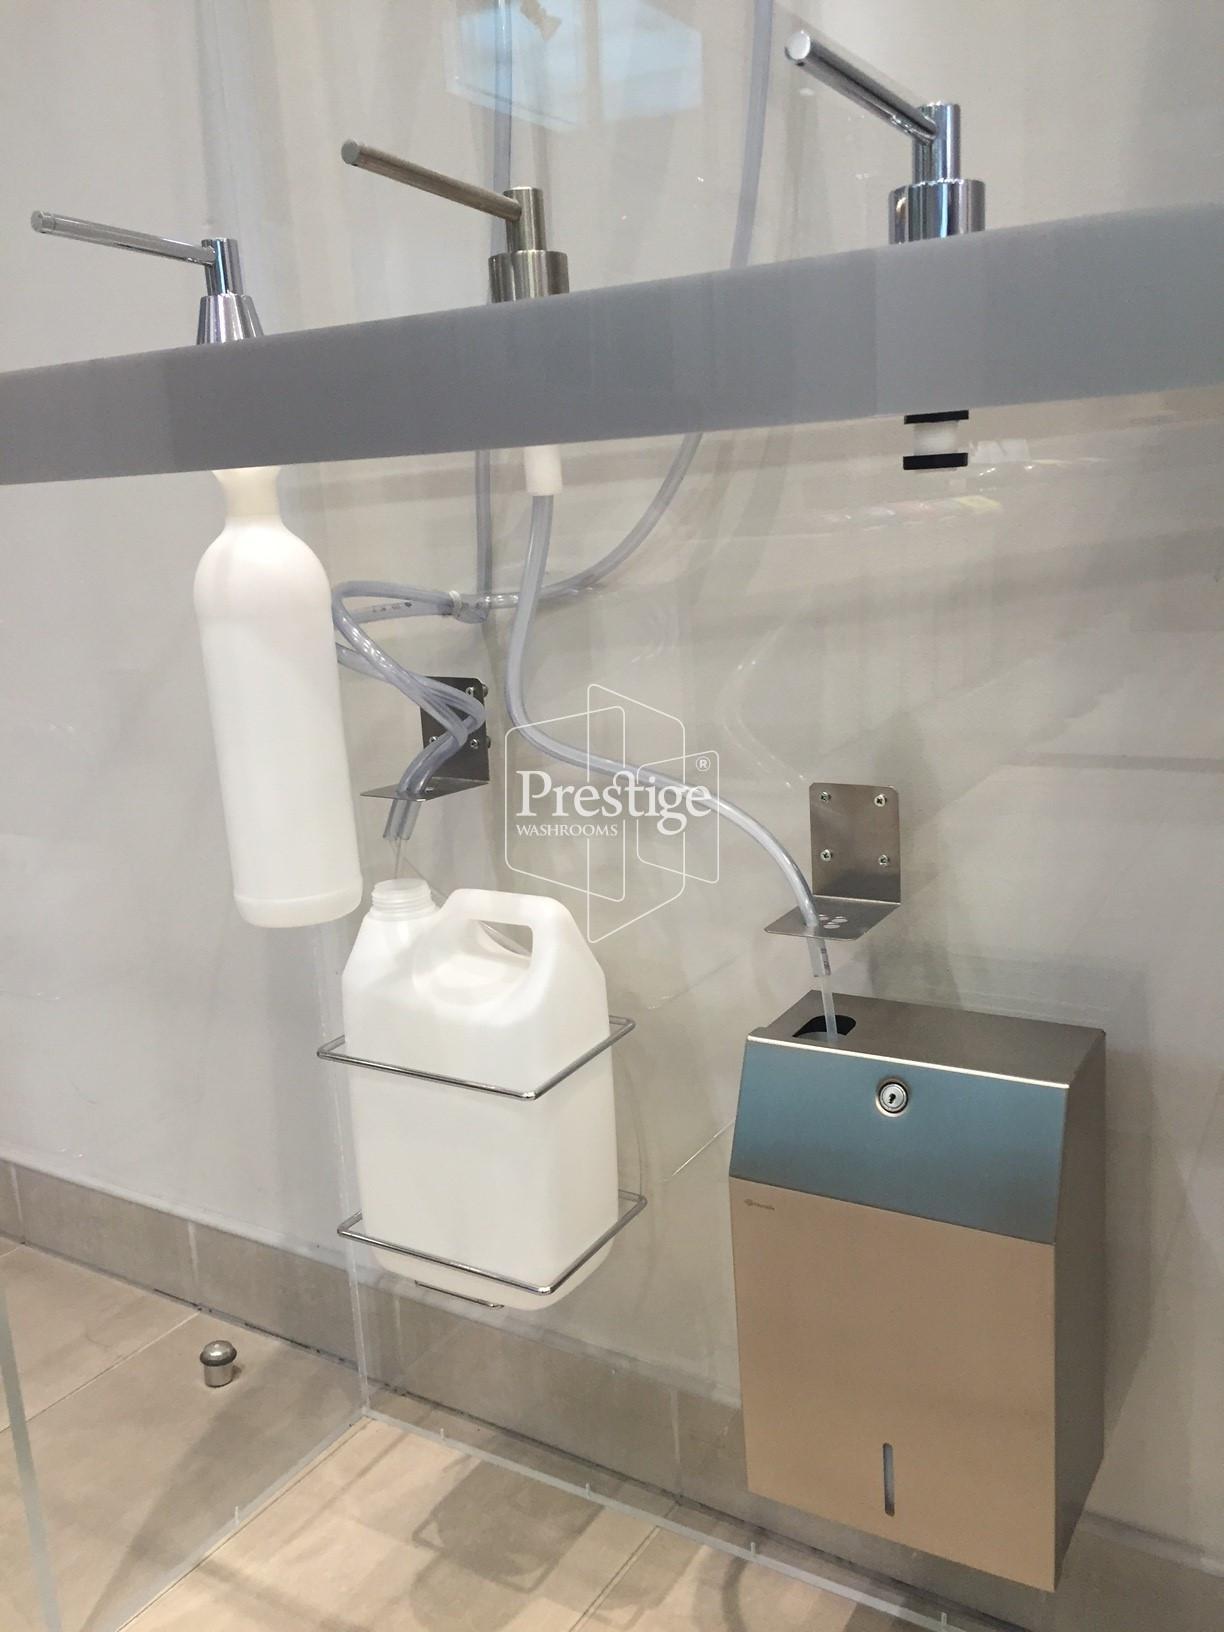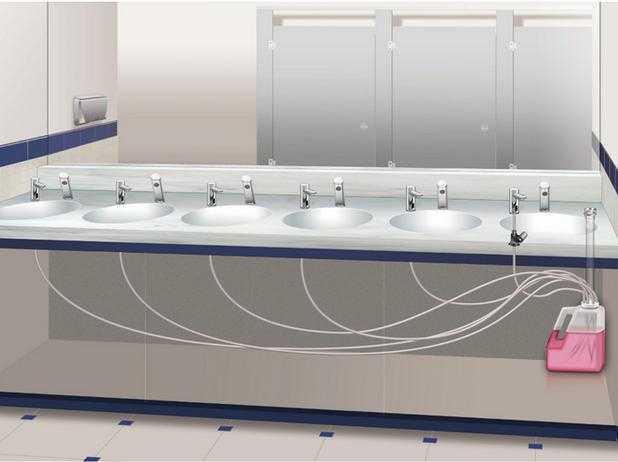The first image is the image on the left, the second image is the image on the right. For the images shown, is this caption "more than 3 sinks are on the same vanity" true? Answer yes or no. Yes. The first image is the image on the left, the second image is the image on the right. Evaluate the accuracy of this statement regarding the images: "More than one cord is visible underneath the faucets and counter-top.". Is it true? Answer yes or no. Yes. 